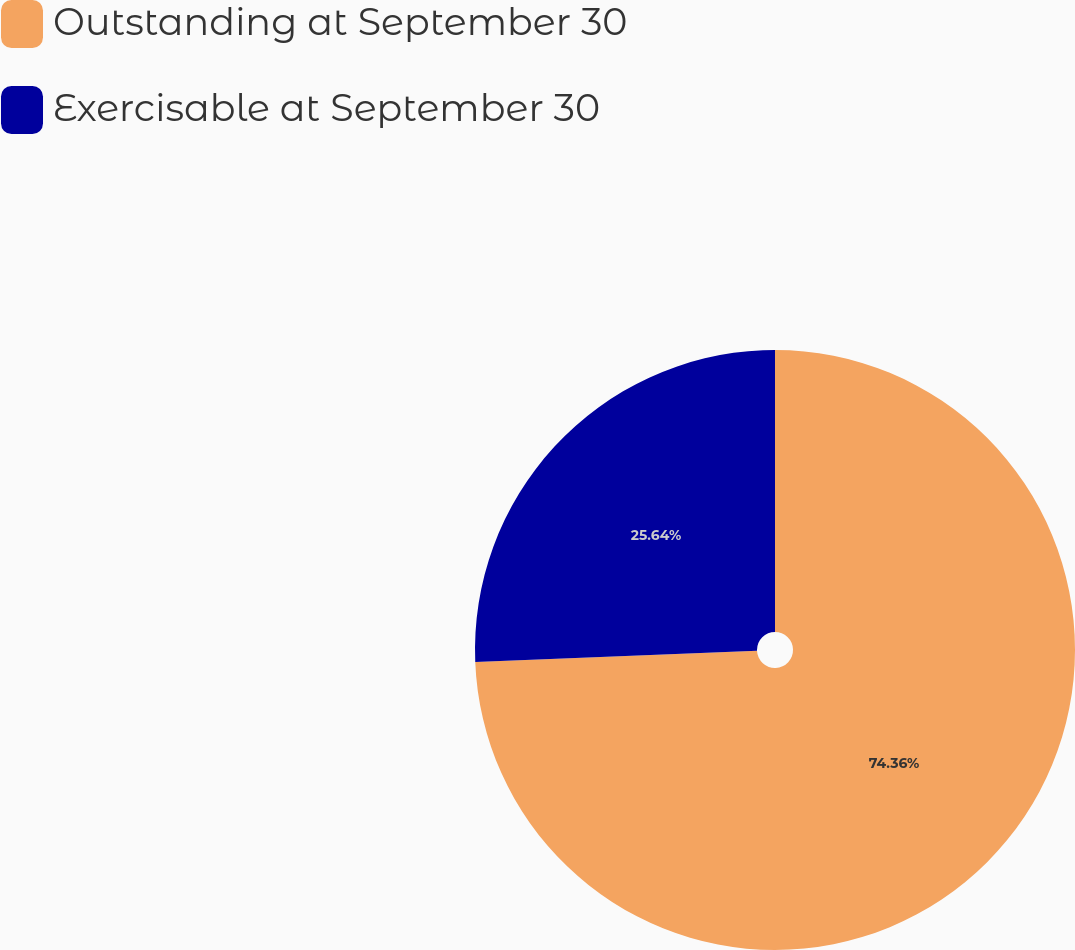<chart> <loc_0><loc_0><loc_500><loc_500><pie_chart><fcel>Outstanding at September 30<fcel>Exercisable at September 30<nl><fcel>74.36%<fcel>25.64%<nl></chart> 